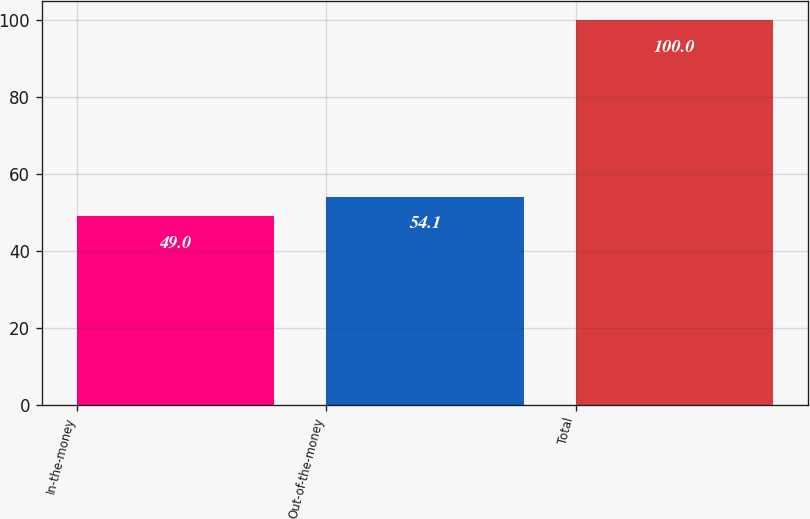Convert chart. <chart><loc_0><loc_0><loc_500><loc_500><bar_chart><fcel>In-the-money<fcel>Out-of-the-money<fcel>Total<nl><fcel>49<fcel>54.1<fcel>100<nl></chart> 